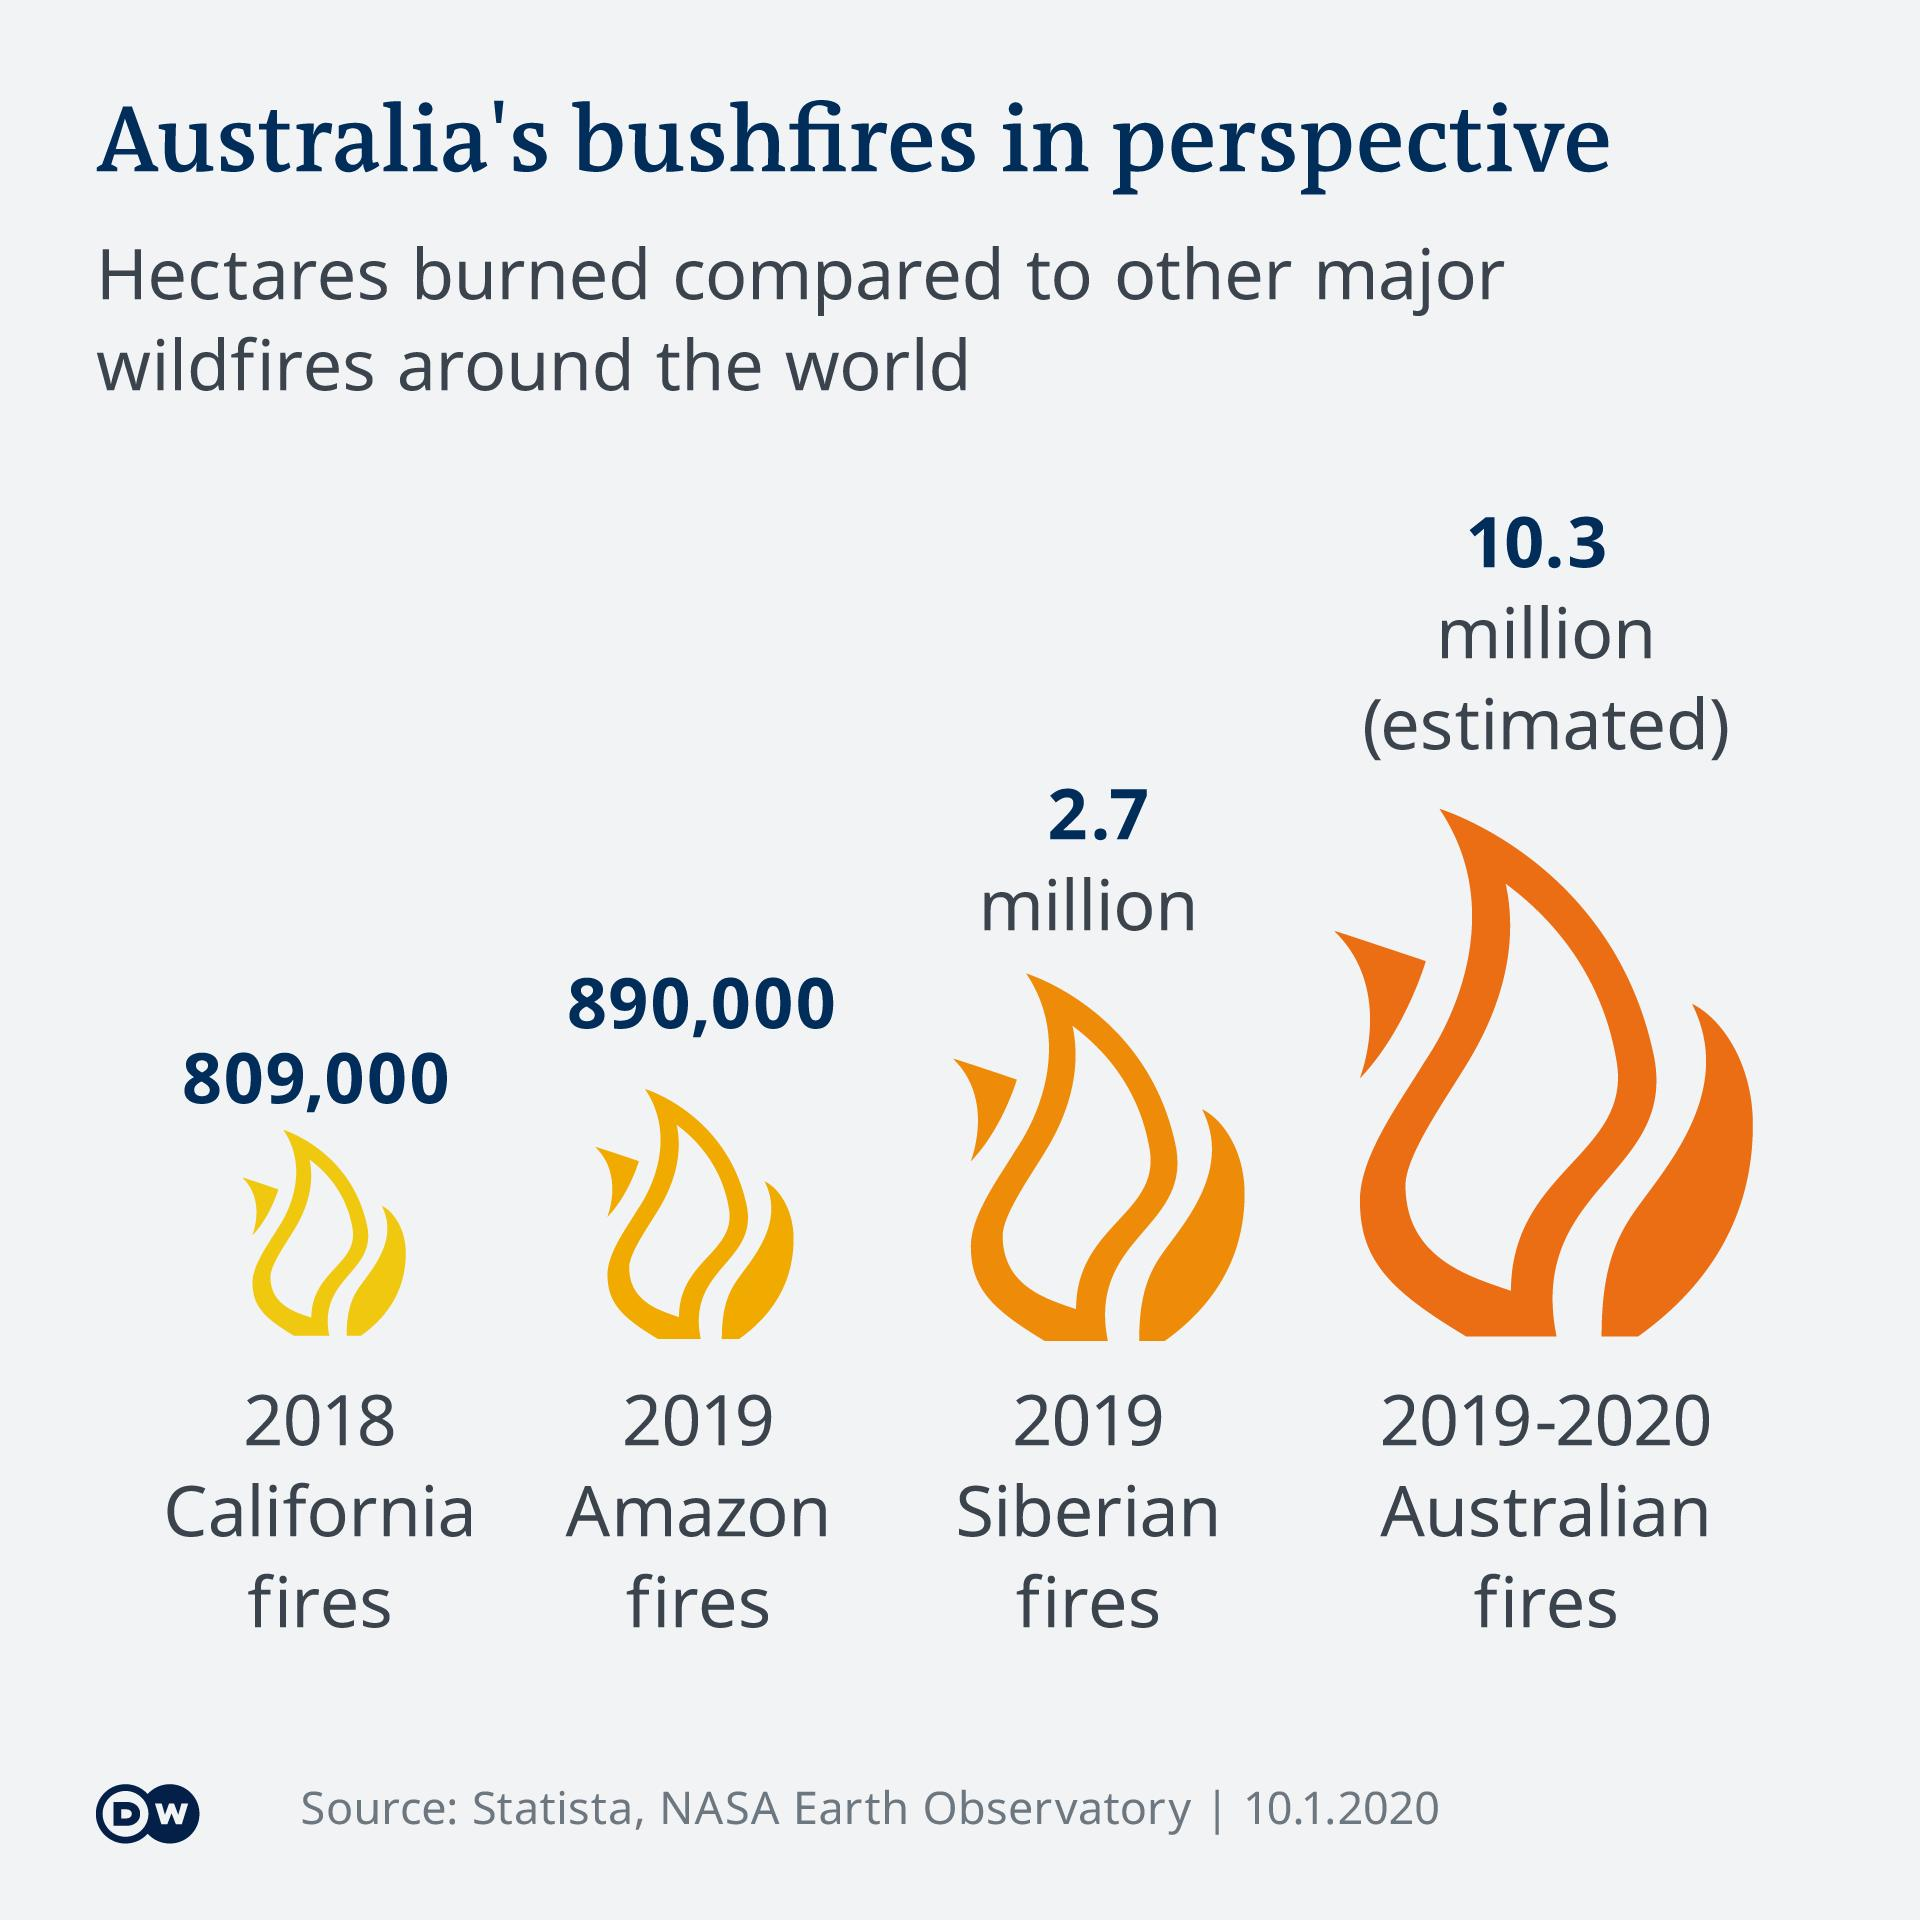Identify some key points in this picture. During the 2019-2020 Australian bushfires, a total of 10.3 million hectares of land were burned. The California Fires in 2018 burned a total of 809,000 hectares of land. In 2019, a significant number of hectares of land in Siberia were affected by devastating fires, resulting in 2.7 million hectares being burned. In 2019, a significant amount of land in the Amazon rainforest, approximately 890,000 hectares, was burned due to fires. 